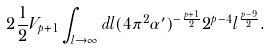<formula> <loc_0><loc_0><loc_500><loc_500>2 \frac { 1 } { 2 } V _ { p + 1 } \int _ { l \to \infty } d l ( 4 \pi ^ { 2 } \alpha ^ { \prime } ) ^ { - \frac { p + 1 } { 2 } } 2 ^ { p - 4 } l ^ { \frac { p - 9 } { 2 } } .</formula> 